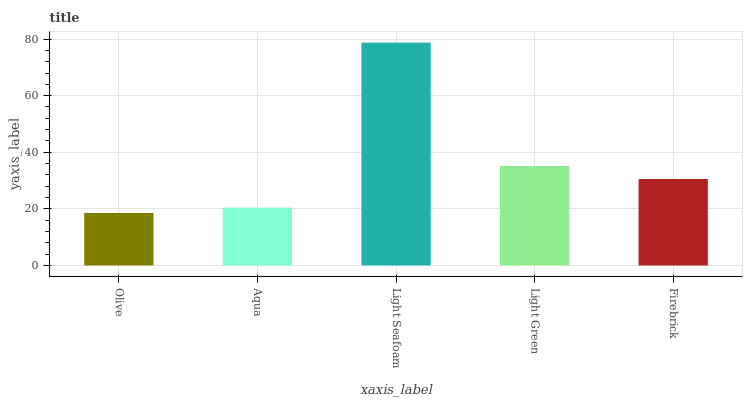Is Olive the minimum?
Answer yes or no. Yes. Is Light Seafoam the maximum?
Answer yes or no. Yes. Is Aqua the minimum?
Answer yes or no. No. Is Aqua the maximum?
Answer yes or no. No. Is Aqua greater than Olive?
Answer yes or no. Yes. Is Olive less than Aqua?
Answer yes or no. Yes. Is Olive greater than Aqua?
Answer yes or no. No. Is Aqua less than Olive?
Answer yes or no. No. Is Firebrick the high median?
Answer yes or no. Yes. Is Firebrick the low median?
Answer yes or no. Yes. Is Olive the high median?
Answer yes or no. No. Is Aqua the low median?
Answer yes or no. No. 